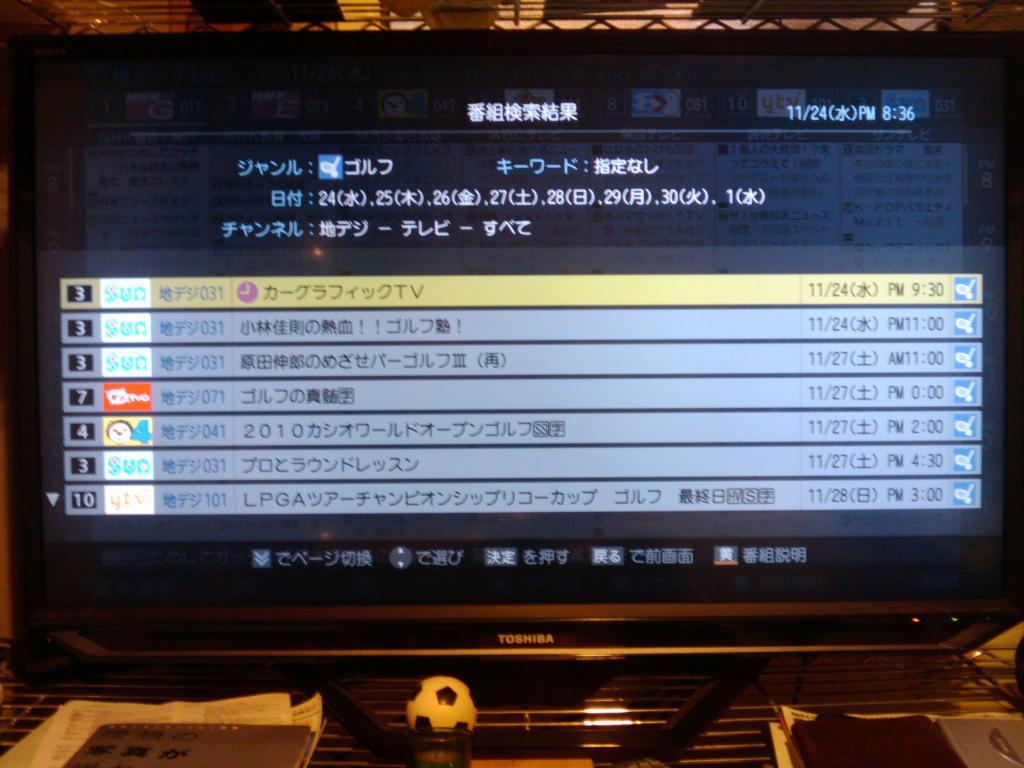<image>
Summarize the visual content of the image. A TV that says Toshiba on the front is showing Chinese channels. 